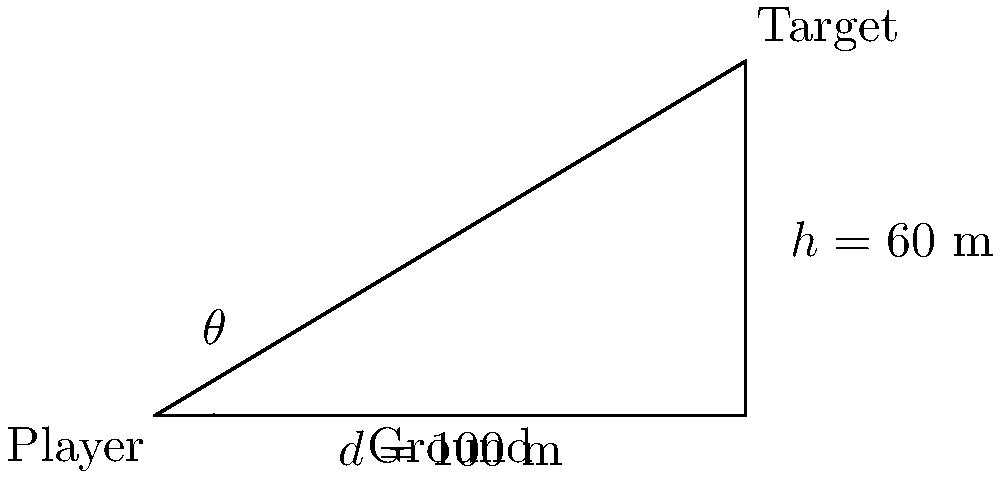As a scout manager, you're analyzing the optimal ball trajectory for your team's long-distance kicks. A player needs to kick the ball to a target that is 100 meters away horizontally and 60 meters above the ground. What should be the angle of elevation (θ) for the kick to reach the target directly? To find the angle of elevation (θ), we can use the trigonometric function tangent. Here's how to solve it step-by-step:

1) In this scenario, we have a right-angled triangle where:
   - The adjacent side (horizontal distance) is 100 meters
   - The opposite side (vertical height) is 60 meters
   - We need to find the angle θ

2) The tangent of an angle in a right-angled triangle is defined as:

   $\tan(\theta) = \frac{\text{opposite}}{\text{adjacent}}$

3) Substituting our values:

   $\tan(\theta) = \frac{60}{100} = 0.6$

4) To find θ, we need to use the inverse tangent (arctan or $\tan^{-1}$):

   $\theta = \tan^{-1}(0.6)$

5) Using a calculator or mathematical tables:

   $\theta \approx 30.96°$

Therefore, the angle of elevation for the optimal ball trajectory is approximately 30.96 degrees.
Answer: $30.96°$ 